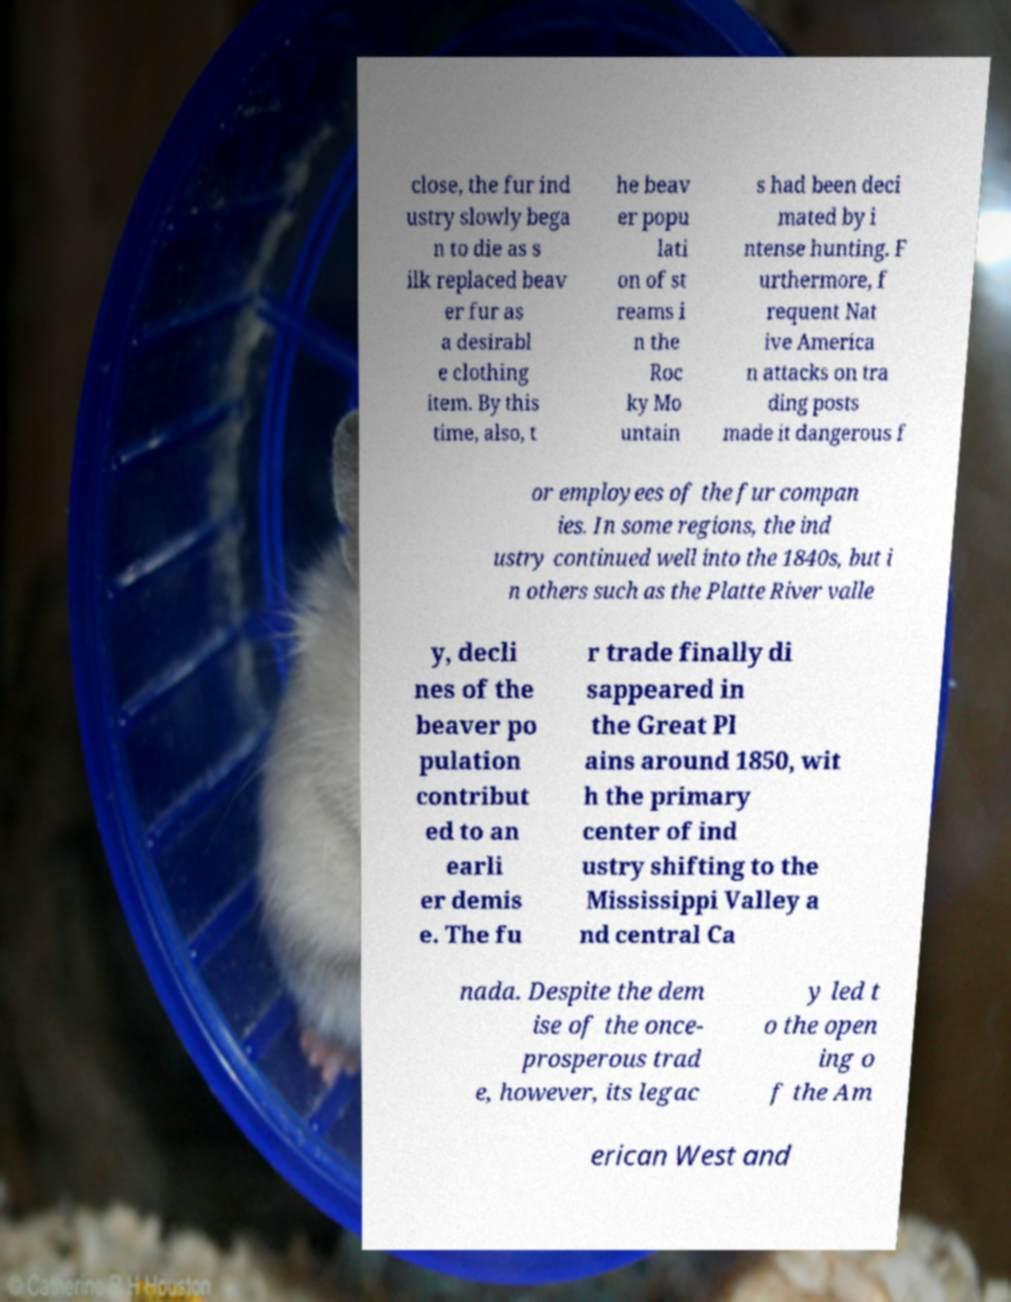For documentation purposes, I need the text within this image transcribed. Could you provide that? close, the fur ind ustry slowly bega n to die as s ilk replaced beav er fur as a desirabl e clothing item. By this time, also, t he beav er popu lati on of st reams i n the Roc ky Mo untain s had been deci mated by i ntense hunting. F urthermore, f requent Nat ive America n attacks on tra ding posts made it dangerous f or employees of the fur compan ies. In some regions, the ind ustry continued well into the 1840s, but i n others such as the Platte River valle y, decli nes of the beaver po pulation contribut ed to an earli er demis e. The fu r trade finally di sappeared in the Great Pl ains around 1850, wit h the primary center of ind ustry shifting to the Mississippi Valley a nd central Ca nada. Despite the dem ise of the once- prosperous trad e, however, its legac y led t o the open ing o f the Am erican West and 